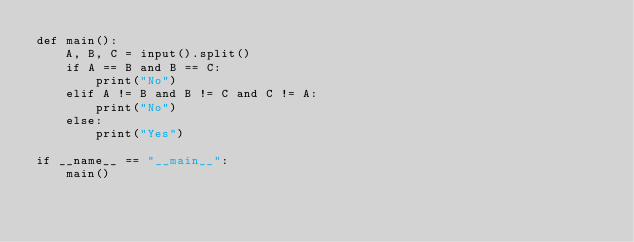Convert code to text. <code><loc_0><loc_0><loc_500><loc_500><_Python_>def main():
    A, B, C = input().split()
    if A == B and B == C:
        print("No")
    elif A != B and B != C and C != A:
        print("No")
    else:
        print("Yes")

if __name__ == "__main__":
    main()</code> 